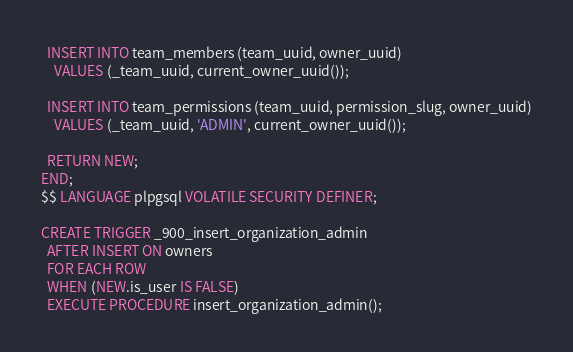Convert code to text. <code><loc_0><loc_0><loc_500><loc_500><_SQL_>
  INSERT INTO team_members (team_uuid, owner_uuid)
    VALUES (_team_uuid, current_owner_uuid());

  INSERT INTO team_permissions (team_uuid, permission_slug, owner_uuid)
    VALUES (_team_uuid, 'ADMIN', current_owner_uuid());

  RETURN NEW;
END;
$$ LANGUAGE plpgsql VOLATILE SECURITY DEFINER;

CREATE TRIGGER _900_insert_organization_admin
  AFTER INSERT ON owners
  FOR EACH ROW
  WHEN (NEW.is_user IS FALSE)
  EXECUTE PROCEDURE insert_organization_admin();
</code> 